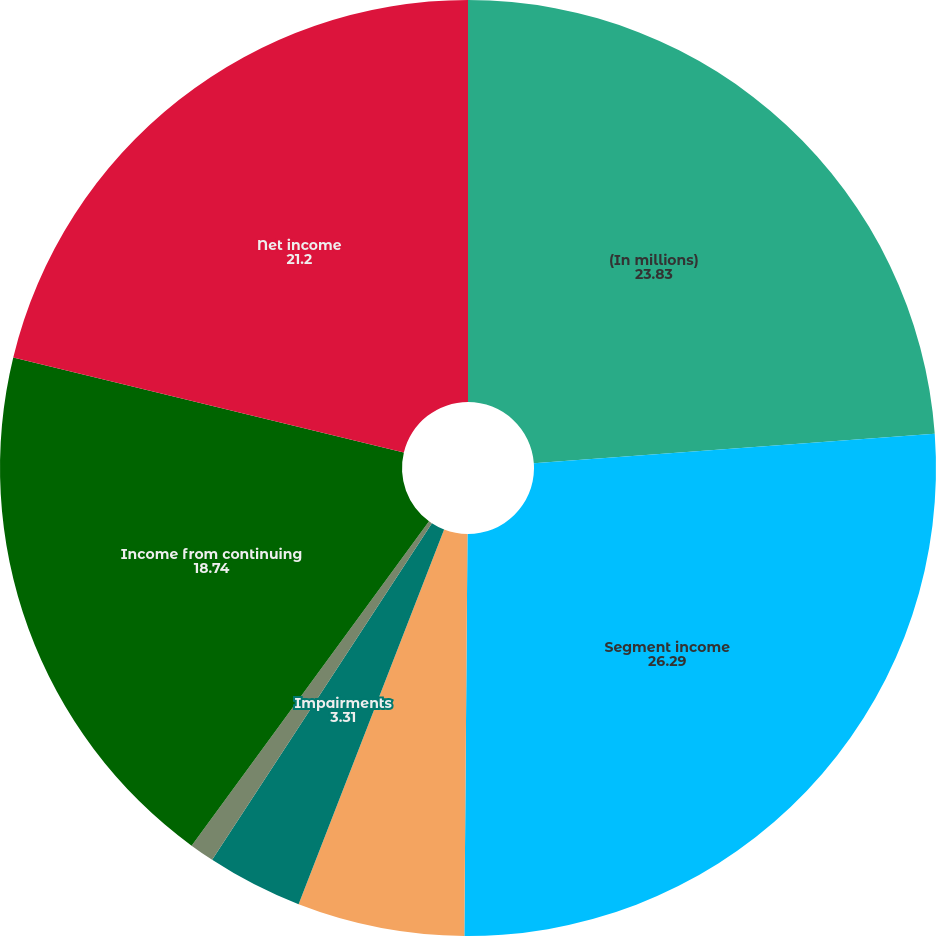Convert chart. <chart><loc_0><loc_0><loc_500><loc_500><pie_chart><fcel>(In millions)<fcel>Segment income<fcel>Corporate and other<fcel>Impairments<fcel>Gain on dispositions<fcel>Income from continuing<fcel>Net income<nl><fcel>23.83%<fcel>26.29%<fcel>5.77%<fcel>3.31%<fcel>0.85%<fcel>18.74%<fcel>21.2%<nl></chart> 